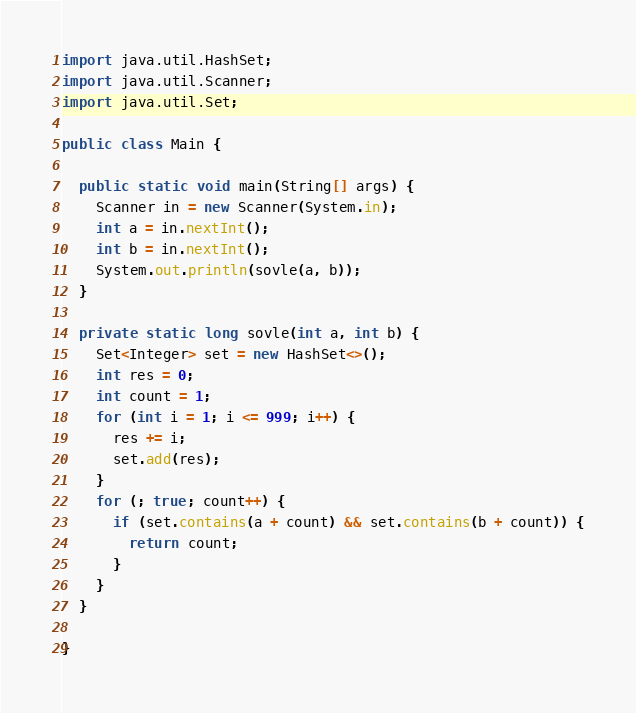<code> <loc_0><loc_0><loc_500><loc_500><_Java_>import java.util.HashSet;
import java.util.Scanner;
import java.util.Set;

public class Main {

  public static void main(String[] args) {
    Scanner in = new Scanner(System.in);
    int a = in.nextInt();
    int b = in.nextInt();
    System.out.println(sovle(a, b));
  }

  private static long sovle(int a, int b) {
    Set<Integer> set = new HashSet<>();
    int res = 0;
    int count = 1;
    for (int i = 1; i <= 999; i++) {
      res += i;
      set.add(res);
    }
    for (; true; count++) {
      if (set.contains(a + count) && set.contains(b + count)) {
        return count;
      }
    }
  }

}
</code> 